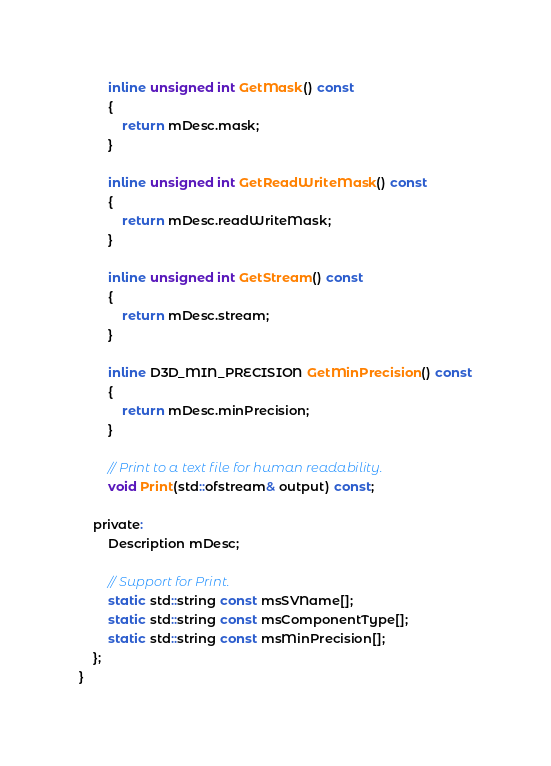Convert code to text. <code><loc_0><loc_0><loc_500><loc_500><_C_>
        inline unsigned int GetMask() const
        {
            return mDesc.mask;
        }

        inline unsigned int GetReadWriteMask() const
        {
            return mDesc.readWriteMask;
        }

        inline unsigned int GetStream() const
        {
            return mDesc.stream;
        }

        inline D3D_MIN_PRECISION GetMinPrecision() const
        {
            return mDesc.minPrecision;
        }

        // Print to a text file for human readability.
        void Print(std::ofstream& output) const;

    private:
        Description mDesc;

        // Support for Print.
        static std::string const msSVName[];
        static std::string const msComponentType[];
        static std::string const msMinPrecision[];
    };
}
</code> 